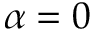<formula> <loc_0><loc_0><loc_500><loc_500>\alpha = 0</formula> 